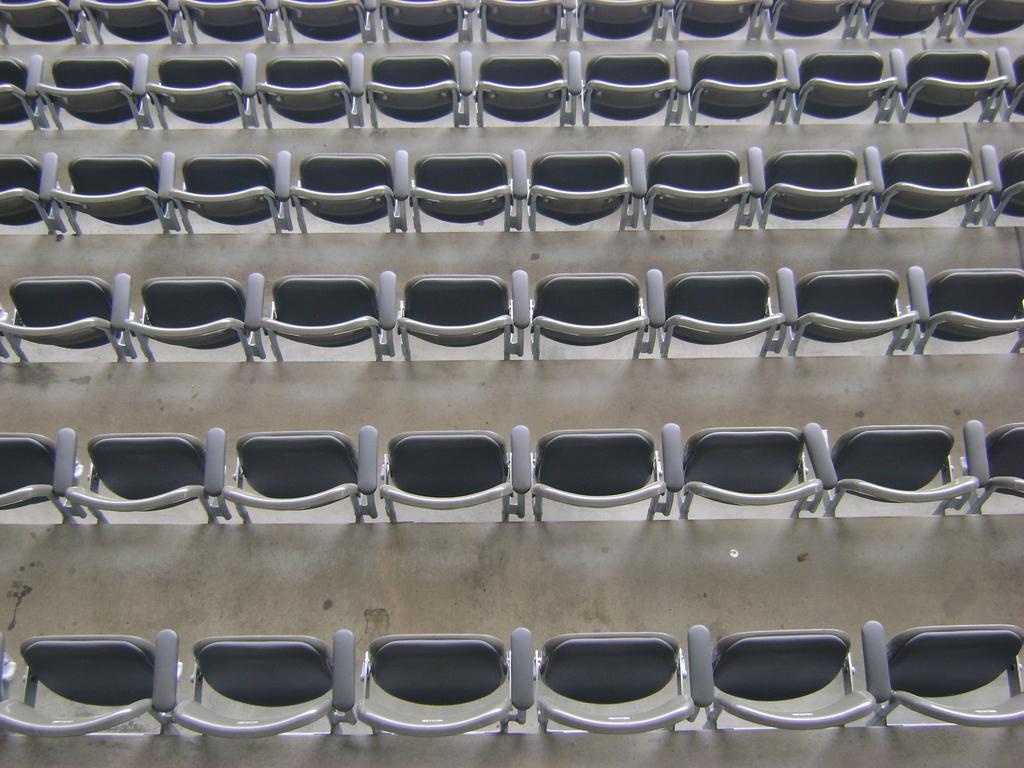Describe this image in one or two sentences. In this image, we can see some stairs and chairs. 